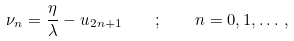<formula> <loc_0><loc_0><loc_500><loc_500>\nu _ { n } = \frac { \eta } { \lambda } - u _ { 2 n + 1 } \quad ; \quad n = 0 , 1 , \dots \, ,</formula> 